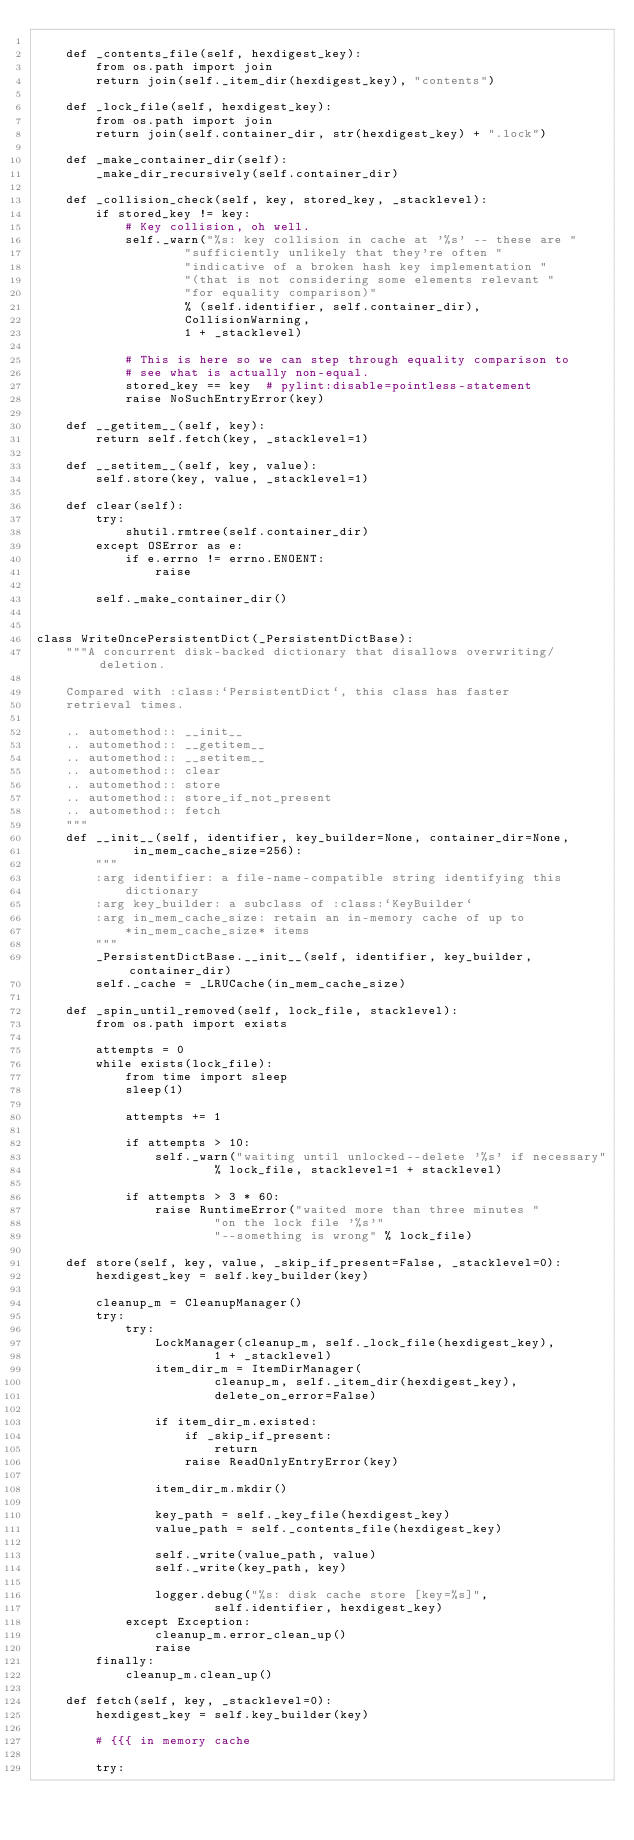<code> <loc_0><loc_0><loc_500><loc_500><_Python_>
    def _contents_file(self, hexdigest_key):
        from os.path import join
        return join(self._item_dir(hexdigest_key), "contents")

    def _lock_file(self, hexdigest_key):
        from os.path import join
        return join(self.container_dir, str(hexdigest_key) + ".lock")

    def _make_container_dir(self):
        _make_dir_recursively(self.container_dir)

    def _collision_check(self, key, stored_key, _stacklevel):
        if stored_key != key:
            # Key collision, oh well.
            self._warn("%s: key collision in cache at '%s' -- these are "
                    "sufficiently unlikely that they're often "
                    "indicative of a broken hash key implementation "
                    "(that is not considering some elements relevant "
                    "for equality comparison)"
                    % (self.identifier, self.container_dir),
                    CollisionWarning,
                    1 + _stacklevel)

            # This is here so we can step through equality comparison to
            # see what is actually non-equal.
            stored_key == key  # pylint:disable=pointless-statement
            raise NoSuchEntryError(key)

    def __getitem__(self, key):
        return self.fetch(key, _stacklevel=1)

    def __setitem__(self, key, value):
        self.store(key, value, _stacklevel=1)

    def clear(self):
        try:
            shutil.rmtree(self.container_dir)
        except OSError as e:
            if e.errno != errno.ENOENT:
                raise

        self._make_container_dir()


class WriteOncePersistentDict(_PersistentDictBase):
    """A concurrent disk-backed dictionary that disallows overwriting/deletion.

    Compared with :class:`PersistentDict`, this class has faster
    retrieval times.

    .. automethod:: __init__
    .. automethod:: __getitem__
    .. automethod:: __setitem__
    .. automethod:: clear
    .. automethod:: store
    .. automethod:: store_if_not_present
    .. automethod:: fetch
    """
    def __init__(self, identifier, key_builder=None, container_dir=None,
             in_mem_cache_size=256):
        """
        :arg identifier: a file-name-compatible string identifying this
            dictionary
        :arg key_builder: a subclass of :class:`KeyBuilder`
        :arg in_mem_cache_size: retain an in-memory cache of up to
            *in_mem_cache_size* items
        """
        _PersistentDictBase.__init__(self, identifier, key_builder, container_dir)
        self._cache = _LRUCache(in_mem_cache_size)

    def _spin_until_removed(self, lock_file, stacklevel):
        from os.path import exists

        attempts = 0
        while exists(lock_file):
            from time import sleep
            sleep(1)

            attempts += 1

            if attempts > 10:
                self._warn("waiting until unlocked--delete '%s' if necessary"
                        % lock_file, stacklevel=1 + stacklevel)

            if attempts > 3 * 60:
                raise RuntimeError("waited more than three minutes "
                        "on the lock file '%s'"
                        "--something is wrong" % lock_file)

    def store(self, key, value, _skip_if_present=False, _stacklevel=0):
        hexdigest_key = self.key_builder(key)

        cleanup_m = CleanupManager()
        try:
            try:
                LockManager(cleanup_m, self._lock_file(hexdigest_key),
                        1 + _stacklevel)
                item_dir_m = ItemDirManager(
                        cleanup_m, self._item_dir(hexdigest_key),
                        delete_on_error=False)

                if item_dir_m.existed:
                    if _skip_if_present:
                        return
                    raise ReadOnlyEntryError(key)

                item_dir_m.mkdir()

                key_path = self._key_file(hexdigest_key)
                value_path = self._contents_file(hexdigest_key)

                self._write(value_path, value)
                self._write(key_path, key)

                logger.debug("%s: disk cache store [key=%s]",
                        self.identifier, hexdigest_key)
            except Exception:
                cleanup_m.error_clean_up()
                raise
        finally:
            cleanup_m.clean_up()

    def fetch(self, key, _stacklevel=0):
        hexdigest_key = self.key_builder(key)

        # {{{ in memory cache

        try:</code> 